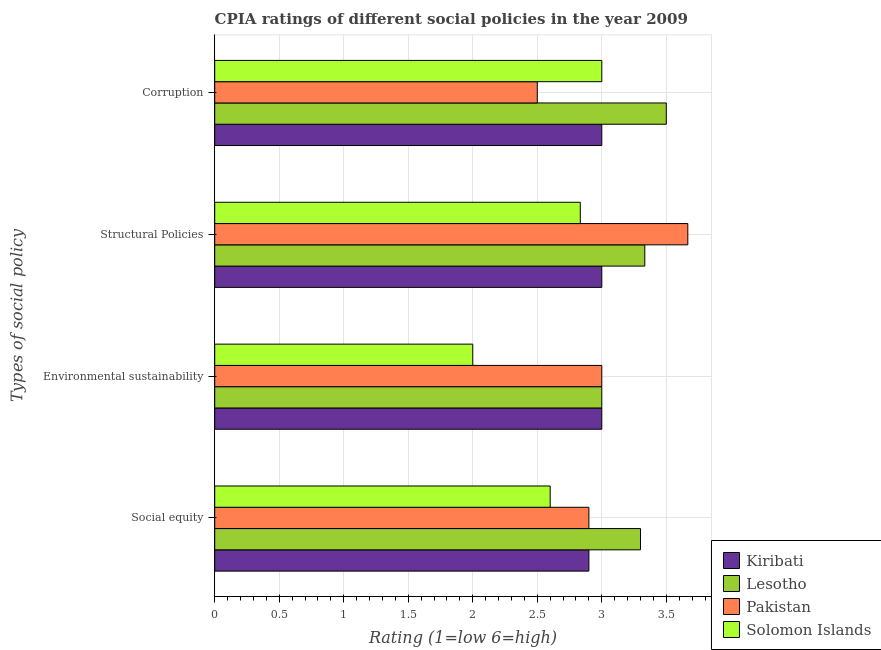How many groups of bars are there?
Give a very brief answer. 4. Are the number of bars per tick equal to the number of legend labels?
Your answer should be very brief. Yes. How many bars are there on the 1st tick from the top?
Make the answer very short. 4. How many bars are there on the 4th tick from the bottom?
Your answer should be very brief. 4. What is the label of the 3rd group of bars from the top?
Offer a very short reply. Environmental sustainability. Across all countries, what is the maximum cpia rating of environmental sustainability?
Give a very brief answer. 3. Across all countries, what is the minimum cpia rating of environmental sustainability?
Provide a succinct answer. 2. In which country was the cpia rating of environmental sustainability maximum?
Keep it short and to the point. Kiribati. In which country was the cpia rating of structural policies minimum?
Provide a succinct answer. Solomon Islands. What is the difference between the cpia rating of environmental sustainability in Pakistan and the cpia rating of social equity in Lesotho?
Keep it short and to the point. -0.3. What is the difference between the cpia rating of structural policies and cpia rating of environmental sustainability in Pakistan?
Offer a very short reply. 0.67. What is the difference between the highest and the second highest cpia rating of social equity?
Provide a succinct answer. 0.4. What is the difference between the highest and the lowest cpia rating of structural policies?
Give a very brief answer. 0.83. What does the 4th bar from the bottom in Social equity represents?
Offer a terse response. Solomon Islands. How many bars are there?
Make the answer very short. 16. Are all the bars in the graph horizontal?
Provide a succinct answer. Yes. How many countries are there in the graph?
Offer a very short reply. 4. What is the difference between two consecutive major ticks on the X-axis?
Give a very brief answer. 0.5. Does the graph contain grids?
Keep it short and to the point. Yes. Where does the legend appear in the graph?
Your response must be concise. Bottom right. How many legend labels are there?
Keep it short and to the point. 4. How are the legend labels stacked?
Keep it short and to the point. Vertical. What is the title of the graph?
Your response must be concise. CPIA ratings of different social policies in the year 2009. What is the label or title of the Y-axis?
Offer a very short reply. Types of social policy. What is the Rating (1=low 6=high) in Kiribati in Social equity?
Give a very brief answer. 2.9. What is the Rating (1=low 6=high) of Lesotho in Social equity?
Provide a short and direct response. 3.3. What is the Rating (1=low 6=high) of Solomon Islands in Social equity?
Your answer should be very brief. 2.6. What is the Rating (1=low 6=high) in Lesotho in Environmental sustainability?
Provide a short and direct response. 3. What is the Rating (1=low 6=high) of Pakistan in Environmental sustainability?
Your answer should be compact. 3. What is the Rating (1=low 6=high) of Solomon Islands in Environmental sustainability?
Keep it short and to the point. 2. What is the Rating (1=low 6=high) of Lesotho in Structural Policies?
Provide a succinct answer. 3.33. What is the Rating (1=low 6=high) in Pakistan in Structural Policies?
Provide a succinct answer. 3.67. What is the Rating (1=low 6=high) of Solomon Islands in Structural Policies?
Your response must be concise. 2.83. What is the Rating (1=low 6=high) in Kiribati in Corruption?
Provide a short and direct response. 3. What is the Rating (1=low 6=high) in Pakistan in Corruption?
Provide a short and direct response. 2.5. What is the Rating (1=low 6=high) in Solomon Islands in Corruption?
Make the answer very short. 3. Across all Types of social policy, what is the maximum Rating (1=low 6=high) of Kiribati?
Your response must be concise. 3. Across all Types of social policy, what is the maximum Rating (1=low 6=high) of Lesotho?
Make the answer very short. 3.5. Across all Types of social policy, what is the maximum Rating (1=low 6=high) in Pakistan?
Give a very brief answer. 3.67. Across all Types of social policy, what is the maximum Rating (1=low 6=high) of Solomon Islands?
Provide a succinct answer. 3. What is the total Rating (1=low 6=high) of Kiribati in the graph?
Provide a succinct answer. 11.9. What is the total Rating (1=low 6=high) in Lesotho in the graph?
Keep it short and to the point. 13.13. What is the total Rating (1=low 6=high) of Pakistan in the graph?
Give a very brief answer. 12.07. What is the total Rating (1=low 6=high) in Solomon Islands in the graph?
Offer a very short reply. 10.43. What is the difference between the Rating (1=low 6=high) of Solomon Islands in Social equity and that in Environmental sustainability?
Offer a very short reply. 0.6. What is the difference between the Rating (1=low 6=high) of Kiribati in Social equity and that in Structural Policies?
Ensure brevity in your answer.  -0.1. What is the difference between the Rating (1=low 6=high) in Lesotho in Social equity and that in Structural Policies?
Your answer should be very brief. -0.03. What is the difference between the Rating (1=low 6=high) in Pakistan in Social equity and that in Structural Policies?
Your answer should be compact. -0.77. What is the difference between the Rating (1=low 6=high) in Solomon Islands in Social equity and that in Structural Policies?
Provide a short and direct response. -0.23. What is the difference between the Rating (1=low 6=high) in Kiribati in Social equity and that in Corruption?
Your response must be concise. -0.1. What is the difference between the Rating (1=low 6=high) in Lesotho in Social equity and that in Corruption?
Offer a terse response. -0.2. What is the difference between the Rating (1=low 6=high) of Pakistan in Social equity and that in Corruption?
Provide a succinct answer. 0.4. What is the difference between the Rating (1=low 6=high) of Kiribati in Environmental sustainability and that in Structural Policies?
Offer a terse response. 0. What is the difference between the Rating (1=low 6=high) in Lesotho in Environmental sustainability and that in Structural Policies?
Offer a terse response. -0.33. What is the difference between the Rating (1=low 6=high) in Pakistan in Environmental sustainability and that in Structural Policies?
Provide a short and direct response. -0.67. What is the difference between the Rating (1=low 6=high) of Solomon Islands in Environmental sustainability and that in Structural Policies?
Make the answer very short. -0.83. What is the difference between the Rating (1=low 6=high) of Kiribati in Environmental sustainability and that in Corruption?
Your response must be concise. 0. What is the difference between the Rating (1=low 6=high) of Lesotho in Environmental sustainability and that in Corruption?
Your answer should be compact. -0.5. What is the difference between the Rating (1=low 6=high) of Pakistan in Environmental sustainability and that in Corruption?
Your answer should be compact. 0.5. What is the difference between the Rating (1=low 6=high) of Solomon Islands in Environmental sustainability and that in Corruption?
Your answer should be compact. -1. What is the difference between the Rating (1=low 6=high) in Pakistan in Structural Policies and that in Corruption?
Your answer should be compact. 1.17. What is the difference between the Rating (1=low 6=high) in Kiribati in Social equity and the Rating (1=low 6=high) in Pakistan in Environmental sustainability?
Keep it short and to the point. -0.1. What is the difference between the Rating (1=low 6=high) in Lesotho in Social equity and the Rating (1=low 6=high) in Pakistan in Environmental sustainability?
Provide a succinct answer. 0.3. What is the difference between the Rating (1=low 6=high) in Pakistan in Social equity and the Rating (1=low 6=high) in Solomon Islands in Environmental sustainability?
Provide a short and direct response. 0.9. What is the difference between the Rating (1=low 6=high) in Kiribati in Social equity and the Rating (1=low 6=high) in Lesotho in Structural Policies?
Your answer should be compact. -0.43. What is the difference between the Rating (1=low 6=high) in Kiribati in Social equity and the Rating (1=low 6=high) in Pakistan in Structural Policies?
Offer a very short reply. -0.77. What is the difference between the Rating (1=low 6=high) of Kiribati in Social equity and the Rating (1=low 6=high) of Solomon Islands in Structural Policies?
Your response must be concise. 0.07. What is the difference between the Rating (1=low 6=high) of Lesotho in Social equity and the Rating (1=low 6=high) of Pakistan in Structural Policies?
Give a very brief answer. -0.37. What is the difference between the Rating (1=low 6=high) of Lesotho in Social equity and the Rating (1=low 6=high) of Solomon Islands in Structural Policies?
Offer a very short reply. 0.47. What is the difference between the Rating (1=low 6=high) of Pakistan in Social equity and the Rating (1=low 6=high) of Solomon Islands in Structural Policies?
Offer a terse response. 0.07. What is the difference between the Rating (1=low 6=high) in Kiribati in Social equity and the Rating (1=low 6=high) in Lesotho in Corruption?
Make the answer very short. -0.6. What is the difference between the Rating (1=low 6=high) of Kiribati in Social equity and the Rating (1=low 6=high) of Pakistan in Corruption?
Your response must be concise. 0.4. What is the difference between the Rating (1=low 6=high) in Lesotho in Social equity and the Rating (1=low 6=high) in Solomon Islands in Corruption?
Make the answer very short. 0.3. What is the difference between the Rating (1=low 6=high) of Kiribati in Environmental sustainability and the Rating (1=low 6=high) of Lesotho in Structural Policies?
Your answer should be very brief. -0.33. What is the difference between the Rating (1=low 6=high) in Kiribati in Environmental sustainability and the Rating (1=low 6=high) in Solomon Islands in Structural Policies?
Keep it short and to the point. 0.17. What is the difference between the Rating (1=low 6=high) of Lesotho in Environmental sustainability and the Rating (1=low 6=high) of Solomon Islands in Structural Policies?
Offer a very short reply. 0.17. What is the difference between the Rating (1=low 6=high) in Kiribati in Environmental sustainability and the Rating (1=low 6=high) in Solomon Islands in Corruption?
Provide a succinct answer. 0. What is the difference between the Rating (1=low 6=high) in Lesotho in Environmental sustainability and the Rating (1=low 6=high) in Pakistan in Corruption?
Offer a terse response. 0.5. What is the difference between the Rating (1=low 6=high) of Lesotho in Environmental sustainability and the Rating (1=low 6=high) of Solomon Islands in Corruption?
Make the answer very short. 0. What is the difference between the Rating (1=low 6=high) in Kiribati in Structural Policies and the Rating (1=low 6=high) in Pakistan in Corruption?
Your response must be concise. 0.5. What is the average Rating (1=low 6=high) in Kiribati per Types of social policy?
Your response must be concise. 2.98. What is the average Rating (1=low 6=high) in Lesotho per Types of social policy?
Your answer should be very brief. 3.28. What is the average Rating (1=low 6=high) in Pakistan per Types of social policy?
Provide a succinct answer. 3.02. What is the average Rating (1=low 6=high) of Solomon Islands per Types of social policy?
Ensure brevity in your answer.  2.61. What is the difference between the Rating (1=low 6=high) of Kiribati and Rating (1=low 6=high) of Lesotho in Social equity?
Provide a succinct answer. -0.4. What is the difference between the Rating (1=low 6=high) in Kiribati and Rating (1=low 6=high) in Pakistan in Social equity?
Ensure brevity in your answer.  0. What is the difference between the Rating (1=low 6=high) in Lesotho and Rating (1=low 6=high) in Solomon Islands in Social equity?
Offer a very short reply. 0.7. What is the difference between the Rating (1=low 6=high) of Pakistan and Rating (1=low 6=high) of Solomon Islands in Social equity?
Your answer should be compact. 0.3. What is the difference between the Rating (1=low 6=high) in Kiribati and Rating (1=low 6=high) in Solomon Islands in Environmental sustainability?
Give a very brief answer. 1. What is the difference between the Rating (1=low 6=high) of Lesotho and Rating (1=low 6=high) of Pakistan in Environmental sustainability?
Give a very brief answer. 0. What is the difference between the Rating (1=low 6=high) in Lesotho and Rating (1=low 6=high) in Solomon Islands in Environmental sustainability?
Your answer should be very brief. 1. What is the difference between the Rating (1=low 6=high) in Pakistan and Rating (1=low 6=high) in Solomon Islands in Environmental sustainability?
Provide a succinct answer. 1. What is the difference between the Rating (1=low 6=high) in Kiribati and Rating (1=low 6=high) in Lesotho in Structural Policies?
Your answer should be very brief. -0.33. What is the difference between the Rating (1=low 6=high) in Kiribati and Rating (1=low 6=high) in Pakistan in Structural Policies?
Your answer should be compact. -0.67. What is the difference between the Rating (1=low 6=high) in Kiribati and Rating (1=low 6=high) in Solomon Islands in Structural Policies?
Offer a very short reply. 0.17. What is the difference between the Rating (1=low 6=high) of Lesotho and Rating (1=low 6=high) of Pakistan in Structural Policies?
Give a very brief answer. -0.33. What is the difference between the Rating (1=low 6=high) in Lesotho and Rating (1=low 6=high) in Solomon Islands in Structural Policies?
Offer a very short reply. 0.5. What is the difference between the Rating (1=low 6=high) of Pakistan and Rating (1=low 6=high) of Solomon Islands in Structural Policies?
Offer a terse response. 0.83. What is the difference between the Rating (1=low 6=high) in Kiribati and Rating (1=low 6=high) in Pakistan in Corruption?
Your answer should be very brief. 0.5. What is the difference between the Rating (1=low 6=high) in Lesotho and Rating (1=low 6=high) in Pakistan in Corruption?
Your response must be concise. 1. What is the difference between the Rating (1=low 6=high) in Lesotho and Rating (1=low 6=high) in Solomon Islands in Corruption?
Keep it short and to the point. 0.5. What is the difference between the Rating (1=low 6=high) in Pakistan and Rating (1=low 6=high) in Solomon Islands in Corruption?
Provide a succinct answer. -0.5. What is the ratio of the Rating (1=low 6=high) in Kiribati in Social equity to that in Environmental sustainability?
Provide a succinct answer. 0.97. What is the ratio of the Rating (1=low 6=high) of Pakistan in Social equity to that in Environmental sustainability?
Keep it short and to the point. 0.97. What is the ratio of the Rating (1=low 6=high) of Kiribati in Social equity to that in Structural Policies?
Your answer should be very brief. 0.97. What is the ratio of the Rating (1=low 6=high) of Lesotho in Social equity to that in Structural Policies?
Ensure brevity in your answer.  0.99. What is the ratio of the Rating (1=low 6=high) of Pakistan in Social equity to that in Structural Policies?
Offer a very short reply. 0.79. What is the ratio of the Rating (1=low 6=high) in Solomon Islands in Social equity to that in Structural Policies?
Offer a very short reply. 0.92. What is the ratio of the Rating (1=low 6=high) of Kiribati in Social equity to that in Corruption?
Your answer should be very brief. 0.97. What is the ratio of the Rating (1=low 6=high) of Lesotho in Social equity to that in Corruption?
Your answer should be very brief. 0.94. What is the ratio of the Rating (1=low 6=high) of Pakistan in Social equity to that in Corruption?
Provide a succinct answer. 1.16. What is the ratio of the Rating (1=low 6=high) in Solomon Islands in Social equity to that in Corruption?
Offer a terse response. 0.87. What is the ratio of the Rating (1=low 6=high) in Pakistan in Environmental sustainability to that in Structural Policies?
Provide a short and direct response. 0.82. What is the ratio of the Rating (1=low 6=high) of Solomon Islands in Environmental sustainability to that in Structural Policies?
Your answer should be compact. 0.71. What is the ratio of the Rating (1=low 6=high) in Kiribati in Environmental sustainability to that in Corruption?
Provide a succinct answer. 1. What is the ratio of the Rating (1=low 6=high) of Lesotho in Environmental sustainability to that in Corruption?
Make the answer very short. 0.86. What is the ratio of the Rating (1=low 6=high) of Pakistan in Environmental sustainability to that in Corruption?
Keep it short and to the point. 1.2. What is the ratio of the Rating (1=low 6=high) in Solomon Islands in Environmental sustainability to that in Corruption?
Make the answer very short. 0.67. What is the ratio of the Rating (1=low 6=high) of Kiribati in Structural Policies to that in Corruption?
Ensure brevity in your answer.  1. What is the ratio of the Rating (1=low 6=high) of Pakistan in Structural Policies to that in Corruption?
Your response must be concise. 1.47. What is the difference between the highest and the second highest Rating (1=low 6=high) in Kiribati?
Make the answer very short. 0. What is the difference between the highest and the second highest Rating (1=low 6=high) in Lesotho?
Your answer should be very brief. 0.17. What is the difference between the highest and the lowest Rating (1=low 6=high) of Lesotho?
Your answer should be compact. 0.5. What is the difference between the highest and the lowest Rating (1=low 6=high) in Solomon Islands?
Your answer should be very brief. 1. 